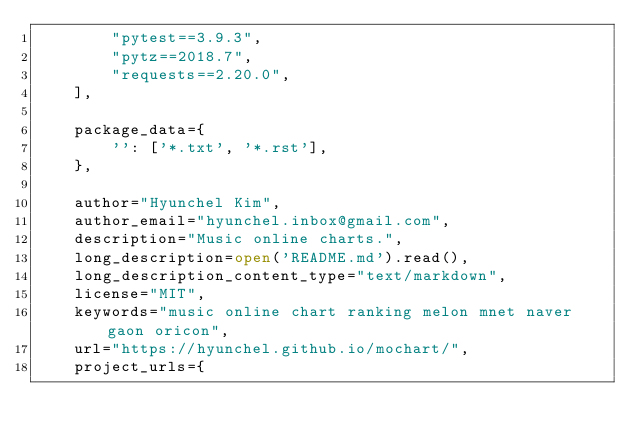<code> <loc_0><loc_0><loc_500><loc_500><_Python_>        "pytest==3.9.3",
        "pytz==2018.7",
        "requests==2.20.0",
    ],

    package_data={
        '': ['*.txt', '*.rst'],
    },

    author="Hyunchel Kim",
    author_email="hyunchel.inbox@gmail.com",
    description="Music online charts.",
    long_description=open('README.md').read(),
    long_description_content_type="text/markdown",
    license="MIT",
    keywords="music online chart ranking melon mnet naver gaon oricon",
    url="https://hyunchel.github.io/mochart/",
    project_urls={</code> 